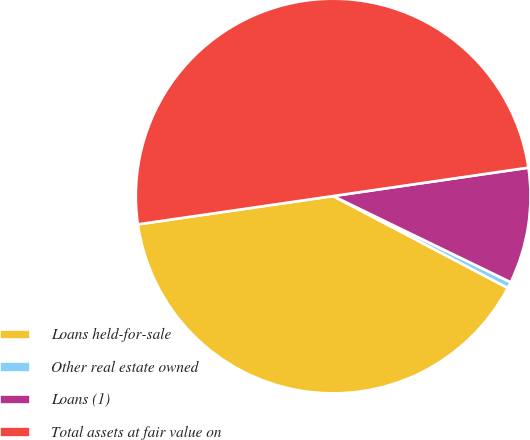<chart> <loc_0><loc_0><loc_500><loc_500><pie_chart><fcel>Loans held-for-sale<fcel>Other real estate owned<fcel>Loans (1)<fcel>Total assets at fair value on<nl><fcel>40.0%<fcel>0.52%<fcel>9.49%<fcel>50.0%<nl></chart> 